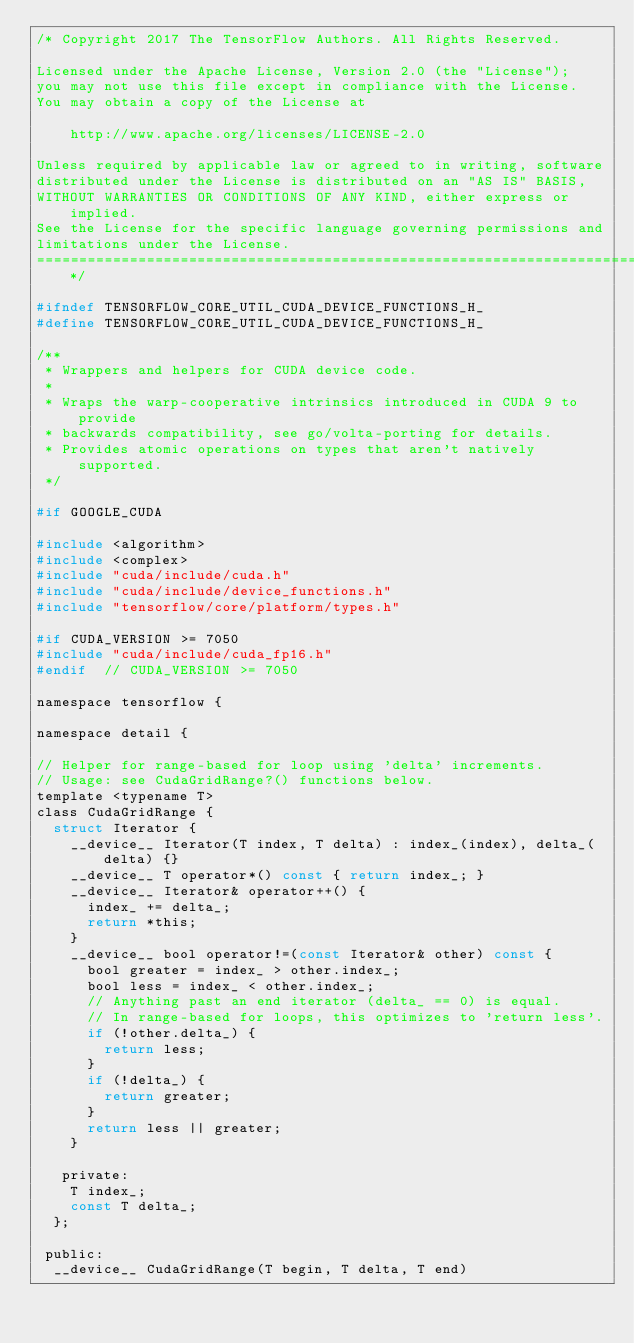Convert code to text. <code><loc_0><loc_0><loc_500><loc_500><_C_>/* Copyright 2017 The TensorFlow Authors. All Rights Reserved.

Licensed under the Apache License, Version 2.0 (the "License");
you may not use this file except in compliance with the License.
You may obtain a copy of the License at

    http://www.apache.org/licenses/LICENSE-2.0

Unless required by applicable law or agreed to in writing, software
distributed under the License is distributed on an "AS IS" BASIS,
WITHOUT WARRANTIES OR CONDITIONS OF ANY KIND, either express or implied.
See the License for the specific language governing permissions and
limitations under the License.
==============================================================================*/

#ifndef TENSORFLOW_CORE_UTIL_CUDA_DEVICE_FUNCTIONS_H_
#define TENSORFLOW_CORE_UTIL_CUDA_DEVICE_FUNCTIONS_H_

/**
 * Wrappers and helpers for CUDA device code.
 *
 * Wraps the warp-cooperative intrinsics introduced in CUDA 9 to provide
 * backwards compatibility, see go/volta-porting for details.
 * Provides atomic operations on types that aren't natively supported.
 */

#if GOOGLE_CUDA

#include <algorithm>
#include <complex>
#include "cuda/include/cuda.h"
#include "cuda/include/device_functions.h"
#include "tensorflow/core/platform/types.h"

#if CUDA_VERSION >= 7050
#include "cuda/include/cuda_fp16.h"
#endif  // CUDA_VERSION >= 7050

namespace tensorflow {

namespace detail {

// Helper for range-based for loop using 'delta' increments.
// Usage: see CudaGridRange?() functions below.
template <typename T>
class CudaGridRange {
  struct Iterator {
    __device__ Iterator(T index, T delta) : index_(index), delta_(delta) {}
    __device__ T operator*() const { return index_; }
    __device__ Iterator& operator++() {
      index_ += delta_;
      return *this;
    }
    __device__ bool operator!=(const Iterator& other) const {
      bool greater = index_ > other.index_;
      bool less = index_ < other.index_;
      // Anything past an end iterator (delta_ == 0) is equal.
      // In range-based for loops, this optimizes to 'return less'.
      if (!other.delta_) {
        return less;
      }
      if (!delta_) {
        return greater;
      }
      return less || greater;
    }

   private:
    T index_;
    const T delta_;
  };

 public:
  __device__ CudaGridRange(T begin, T delta, T end)</code> 